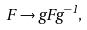Convert formula to latex. <formula><loc_0><loc_0><loc_500><loc_500>F \rightarrow g F g ^ { - 1 } ,</formula> 